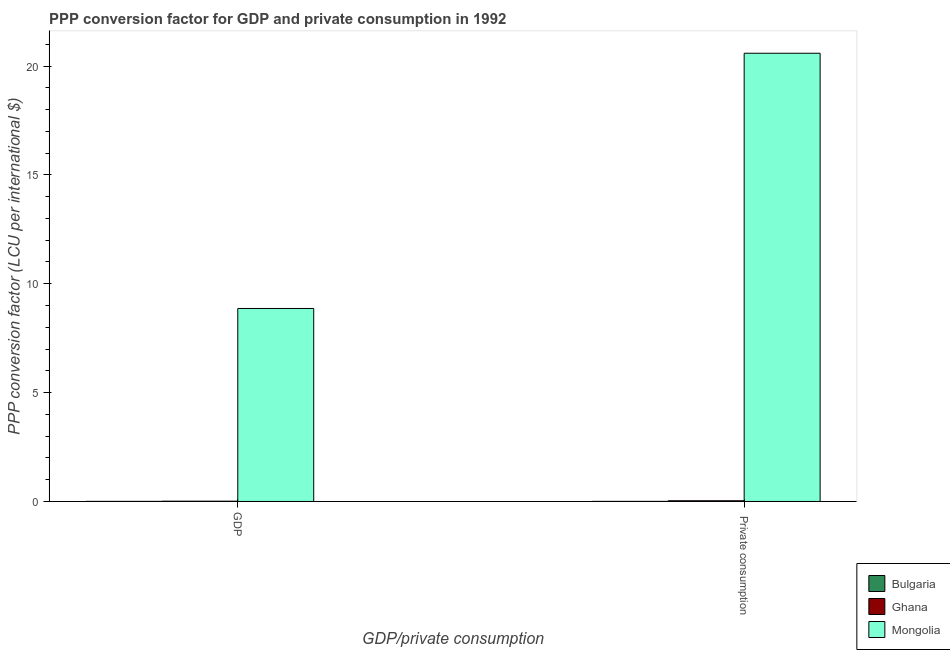Are the number of bars on each tick of the X-axis equal?
Your answer should be compact. Yes. How many bars are there on the 2nd tick from the left?
Make the answer very short. 3. What is the label of the 1st group of bars from the left?
Your answer should be very brief. GDP. What is the ppp conversion factor for private consumption in Bulgaria?
Your response must be concise. 0. Across all countries, what is the maximum ppp conversion factor for gdp?
Your answer should be compact. 8.86. Across all countries, what is the minimum ppp conversion factor for gdp?
Make the answer very short. 0. In which country was the ppp conversion factor for private consumption maximum?
Ensure brevity in your answer.  Mongolia. What is the total ppp conversion factor for gdp in the graph?
Offer a terse response. 8.88. What is the difference between the ppp conversion factor for private consumption in Mongolia and that in Bulgaria?
Give a very brief answer. 20.58. What is the difference between the ppp conversion factor for gdp in Bulgaria and the ppp conversion factor for private consumption in Mongolia?
Give a very brief answer. -20.58. What is the average ppp conversion factor for gdp per country?
Your response must be concise. 2.96. What is the difference between the ppp conversion factor for private consumption and ppp conversion factor for gdp in Ghana?
Ensure brevity in your answer.  0.02. In how many countries, is the ppp conversion factor for gdp greater than 20 LCU?
Keep it short and to the point. 0. What is the ratio of the ppp conversion factor for private consumption in Ghana to that in Mongolia?
Ensure brevity in your answer.  0. Is the ppp conversion factor for private consumption in Bulgaria less than that in Mongolia?
Ensure brevity in your answer.  Yes. In how many countries, is the ppp conversion factor for private consumption greater than the average ppp conversion factor for private consumption taken over all countries?
Your response must be concise. 1. What does the 3rd bar from the left in GDP represents?
Provide a succinct answer. Mongolia. How many bars are there?
Keep it short and to the point. 6. Are the values on the major ticks of Y-axis written in scientific E-notation?
Your answer should be very brief. No. Does the graph contain any zero values?
Make the answer very short. No. Does the graph contain grids?
Ensure brevity in your answer.  No. How many legend labels are there?
Offer a very short reply. 3. How are the legend labels stacked?
Your answer should be very brief. Vertical. What is the title of the graph?
Offer a very short reply. PPP conversion factor for GDP and private consumption in 1992. Does "Yemen, Rep." appear as one of the legend labels in the graph?
Your answer should be compact. No. What is the label or title of the X-axis?
Your answer should be very brief. GDP/private consumption. What is the label or title of the Y-axis?
Keep it short and to the point. PPP conversion factor (LCU per international $). What is the PPP conversion factor (LCU per international $) in Bulgaria in GDP?
Your response must be concise. 0. What is the PPP conversion factor (LCU per international $) of Ghana in GDP?
Make the answer very short. 0.01. What is the PPP conversion factor (LCU per international $) in Mongolia in GDP?
Give a very brief answer. 8.86. What is the PPP conversion factor (LCU per international $) of Bulgaria in  Private consumption?
Offer a terse response. 0. What is the PPP conversion factor (LCU per international $) in Ghana in  Private consumption?
Give a very brief answer. 0.03. What is the PPP conversion factor (LCU per international $) in Mongolia in  Private consumption?
Provide a succinct answer. 20.59. Across all GDP/private consumption, what is the maximum PPP conversion factor (LCU per international $) in Bulgaria?
Your response must be concise. 0. Across all GDP/private consumption, what is the maximum PPP conversion factor (LCU per international $) in Ghana?
Offer a very short reply. 0.03. Across all GDP/private consumption, what is the maximum PPP conversion factor (LCU per international $) of Mongolia?
Your response must be concise. 20.59. Across all GDP/private consumption, what is the minimum PPP conversion factor (LCU per international $) in Bulgaria?
Provide a short and direct response. 0. Across all GDP/private consumption, what is the minimum PPP conversion factor (LCU per international $) of Ghana?
Ensure brevity in your answer.  0.01. Across all GDP/private consumption, what is the minimum PPP conversion factor (LCU per international $) in Mongolia?
Your response must be concise. 8.86. What is the total PPP conversion factor (LCU per international $) in Bulgaria in the graph?
Provide a succinct answer. 0.01. What is the total PPP conversion factor (LCU per international $) of Ghana in the graph?
Offer a terse response. 0.05. What is the total PPP conversion factor (LCU per international $) of Mongolia in the graph?
Give a very brief answer. 29.45. What is the difference between the PPP conversion factor (LCU per international $) of Bulgaria in GDP and that in  Private consumption?
Your answer should be compact. -0. What is the difference between the PPP conversion factor (LCU per international $) in Ghana in GDP and that in  Private consumption?
Your answer should be very brief. -0.02. What is the difference between the PPP conversion factor (LCU per international $) of Mongolia in GDP and that in  Private consumption?
Your answer should be compact. -11.72. What is the difference between the PPP conversion factor (LCU per international $) in Bulgaria in GDP and the PPP conversion factor (LCU per international $) in Ghana in  Private consumption?
Your answer should be very brief. -0.03. What is the difference between the PPP conversion factor (LCU per international $) in Bulgaria in GDP and the PPP conversion factor (LCU per international $) in Mongolia in  Private consumption?
Offer a terse response. -20.58. What is the difference between the PPP conversion factor (LCU per international $) of Ghana in GDP and the PPP conversion factor (LCU per international $) of Mongolia in  Private consumption?
Provide a succinct answer. -20.57. What is the average PPP conversion factor (LCU per international $) of Bulgaria per GDP/private consumption?
Your response must be concise. 0. What is the average PPP conversion factor (LCU per international $) in Ghana per GDP/private consumption?
Ensure brevity in your answer.  0.02. What is the average PPP conversion factor (LCU per international $) of Mongolia per GDP/private consumption?
Provide a succinct answer. 14.73. What is the difference between the PPP conversion factor (LCU per international $) of Bulgaria and PPP conversion factor (LCU per international $) of Ghana in GDP?
Your response must be concise. -0.01. What is the difference between the PPP conversion factor (LCU per international $) of Bulgaria and PPP conversion factor (LCU per international $) of Mongolia in GDP?
Offer a very short reply. -8.86. What is the difference between the PPP conversion factor (LCU per international $) in Ghana and PPP conversion factor (LCU per international $) in Mongolia in GDP?
Offer a terse response. -8.85. What is the difference between the PPP conversion factor (LCU per international $) of Bulgaria and PPP conversion factor (LCU per international $) of Ghana in  Private consumption?
Your answer should be very brief. -0.03. What is the difference between the PPP conversion factor (LCU per international $) of Bulgaria and PPP conversion factor (LCU per international $) of Mongolia in  Private consumption?
Offer a very short reply. -20.58. What is the difference between the PPP conversion factor (LCU per international $) of Ghana and PPP conversion factor (LCU per international $) of Mongolia in  Private consumption?
Your answer should be very brief. -20.55. What is the ratio of the PPP conversion factor (LCU per international $) in Bulgaria in GDP to that in  Private consumption?
Provide a succinct answer. 0.96. What is the ratio of the PPP conversion factor (LCU per international $) of Ghana in GDP to that in  Private consumption?
Provide a succinct answer. 0.41. What is the ratio of the PPP conversion factor (LCU per international $) of Mongolia in GDP to that in  Private consumption?
Give a very brief answer. 0.43. What is the difference between the highest and the second highest PPP conversion factor (LCU per international $) of Bulgaria?
Offer a very short reply. 0. What is the difference between the highest and the second highest PPP conversion factor (LCU per international $) of Ghana?
Offer a terse response. 0.02. What is the difference between the highest and the second highest PPP conversion factor (LCU per international $) in Mongolia?
Ensure brevity in your answer.  11.72. What is the difference between the highest and the lowest PPP conversion factor (LCU per international $) in Bulgaria?
Provide a succinct answer. 0. What is the difference between the highest and the lowest PPP conversion factor (LCU per international $) in Ghana?
Provide a short and direct response. 0.02. What is the difference between the highest and the lowest PPP conversion factor (LCU per international $) in Mongolia?
Your answer should be compact. 11.72. 